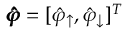<formula> <loc_0><loc_0><loc_500><loc_500>\pm b { \hat { \varphi } } = [ \hat { \varphi } _ { \uparrow } , \hat { \varphi } _ { \downarrow } ] ^ { T }</formula> 